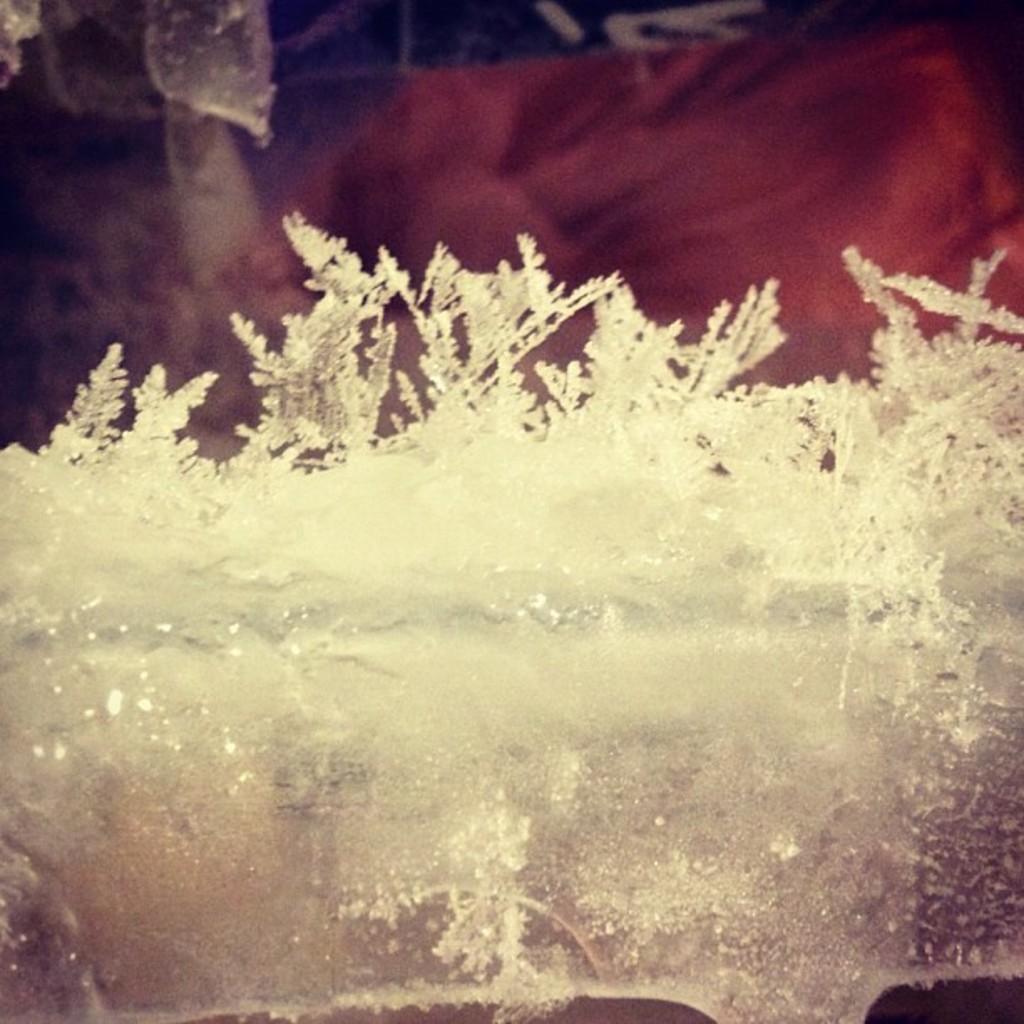In one or two sentences, can you explain what this image depicts? In the center of the image there is ice. 